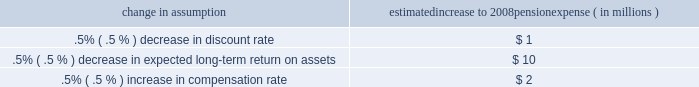Recent accounting pronouncements see note 1 accounting policies in the notes to consolidated financial statements in item 8 of this report for additional information on the following recent accounting pronouncements that are relevant to our business , including a description of each new pronouncement , the required date of adoption , our planned date of adoption , and the expected impact on our consolidated financial statements .
All of the following pronouncements were issued by the fasb unless otherwise noted .
The following were issued in 2007 : 2022 sfas 141 ( r ) , 201cbusiness combinations 201d 2022 sfas 160 , 201caccounting and reporting of noncontrolling interests in consolidated financial statements , an amendment of arb no .
51 201d 2022 in november 2007 , the sec issued staff accounting bulletin no .
109 , 2022 in june 2007 , the aicpa issued statement of position 07-1 , 201cclarification of the scope of the audit and accounting guide 201cinvestment companies 201d and accounting by parent companies and equity method investors for investments in investment companies . 201d the fasb issued a final fsp in february 2008 which indefinitely delays the effective date of aicpa sop 07-1 .
2022 fasb staff position no .
( 201cfsp 201d ) fin 46 ( r ) 7 , 201capplication of fasb interpretation no .
46 ( r ) to investment companies 201d 2022 fsp fin 48-1 , 201cdefinition of settlement in fasb interpretation ( 201cfin 201d ) no .
48 201d 2022 sfas 159 , 201cthe fair value option for financial assets and financial liabilities 2013 including an amendment of fasb statement no .
115 201d the following were issued during 2006 : 2022 sfas 158 , 201cemployers 2019 accounting for defined benefit pension and other postretirement benefit plans 2013 an amendment of fasb statements no .
87 , 88 , 106 and 132 ( r ) 201d ( 201csfas 158 201d ) 2022 sfas 157 , 201cfair value measurements 201d 2022 fin 48 , 201caccounting for uncertainty in income taxes 2013 an interpretation of fasb statement no .
109 201d 2022 fsp fas 13-2 , 201caccounting for a change or projected change in the timing of cash flows relating to income taxes generated by a leveraged lease transaction 201d 2022 sfas 156 , 201caccounting for servicing of financial assets 2013 an amendment of fasb statement no .
140 201d 2022 sfas 155 , 201caccounting for certain hybrid financial instruments 2013 an amendment of fasb statements no .
133 and 140 201d 2022 the emerging issues task force ( 201ceitf 201d ) of the fasb issued eitf issue 06-4 , 201caccounting for deferred compensation and postretirement benefit aspects of endorsement split-dollar life insurance arrangements 201d status of defined benefit pension plan we have a noncontributory , qualified defined benefit pension plan ( 201cplan 201d or 201cpension plan 201d ) covering eligible employees .
Benefits are derived from a cash balance formula based on compensation levels , age and length of service .
Pension contributions are based on an actuarially determined amount necessary to fund total benefits payable to plan participants .
Consistent with our investment strategy , plan assets are currently approximately 60% ( 60 % ) invested in equity investments with most of the remainder invested in fixed income instruments .
Plan fiduciaries determine and review the plan 2019s investment policy .
We calculate the expense associated with the pension plan in accordance with sfas 87 , 201cemployers 2019 accounting for pensions , 201d and we use assumptions and methods that are compatible with the requirements of sfas 87 , including a policy of reflecting trust assets at their fair market value .
On an annual basis , we review the actuarial assumptions related to the pension plan , including the discount rate , the rate of compensation increase and the expected return on plan assets .
Neither the discount rate nor the compensation increase assumptions significantly affects pension expense .
The expected long-term return on assets assumption does significantly affect pension expense .
The expected long-term return on plan assets for determining net periodic pension cost for 2007 was 8.25% ( 8.25 % ) , unchanged from 2006 .
Under current accounting rules , the difference between expected long-term returns and actual returns is accumulated and amortized to pension expense over future periods .
Each one percentage point difference in actual return compared with our expected return causes expense in subsequent years to change by up to $ 4 million as the impact is amortized into results of operations .
The table below reflects the estimated effects on pension expense of certain changes in assumptions , using 2008 estimated expense as a baseline .
Change in assumption estimated increase to 2008 pension expense ( in millions ) .
We currently estimate a pretax pension benefit of $ 26 million in 2008 compared with a pretax benefit of $ 30 million in .
Does a .5% ( .5 % ) decrease in discount rate have a greater impact on pension expense than a .5% ( .5 % ) decrease in expected long-term return on assets? 
Computations: (1 > 10)
Answer: no. 